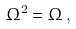<formula> <loc_0><loc_0><loc_500><loc_500>\Omega ^ { 2 } = \Omega \, ,</formula> 